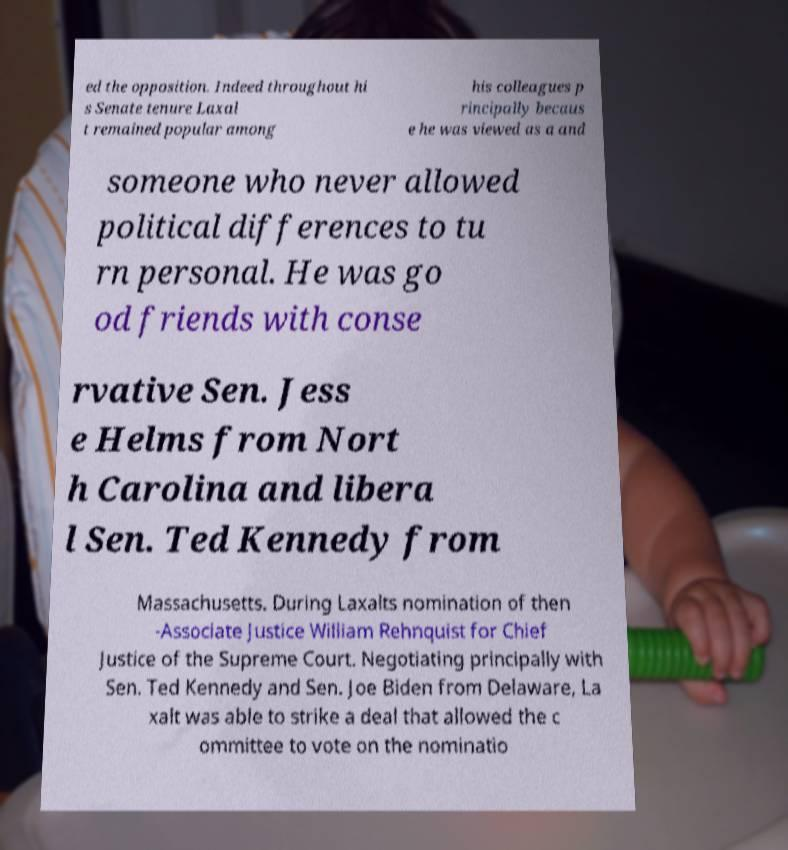What messages or text are displayed in this image? I need them in a readable, typed format. ed the opposition. Indeed throughout hi s Senate tenure Laxal t remained popular among his colleagues p rincipally becaus e he was viewed as a and someone who never allowed political differences to tu rn personal. He was go od friends with conse rvative Sen. Jess e Helms from Nort h Carolina and libera l Sen. Ted Kennedy from Massachusetts. During Laxalts nomination of then -Associate Justice William Rehnquist for Chief Justice of the Supreme Court. Negotiating principally with Sen. Ted Kennedy and Sen. Joe Biden from Delaware, La xalt was able to strike a deal that allowed the c ommittee to vote on the nominatio 